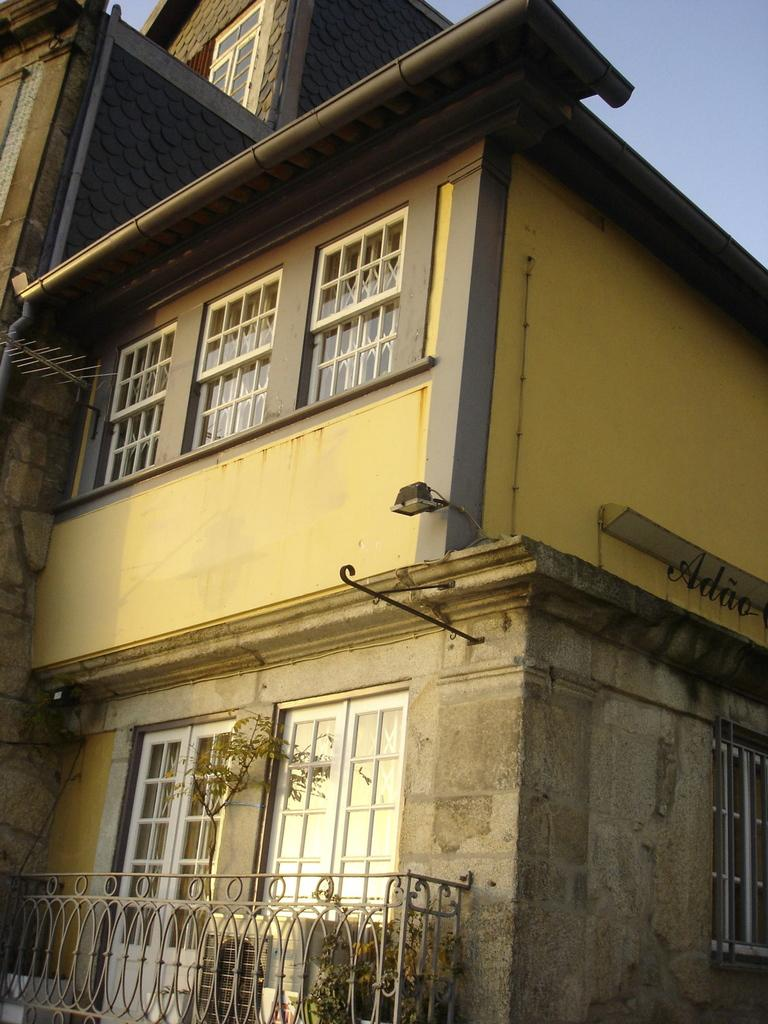What is the main structure in the image? There is a building in the center of the image. What features can be seen on the building? The building has windows and doors. What is located in front of the building? There is a fence in front of the building. How much salt is on the windows of the building in the image? There is no salt visible on the windows of the building in the image. Can you describe the wax used to create the doors in the image? There is no mention of wax being used to create the doors in the image. 